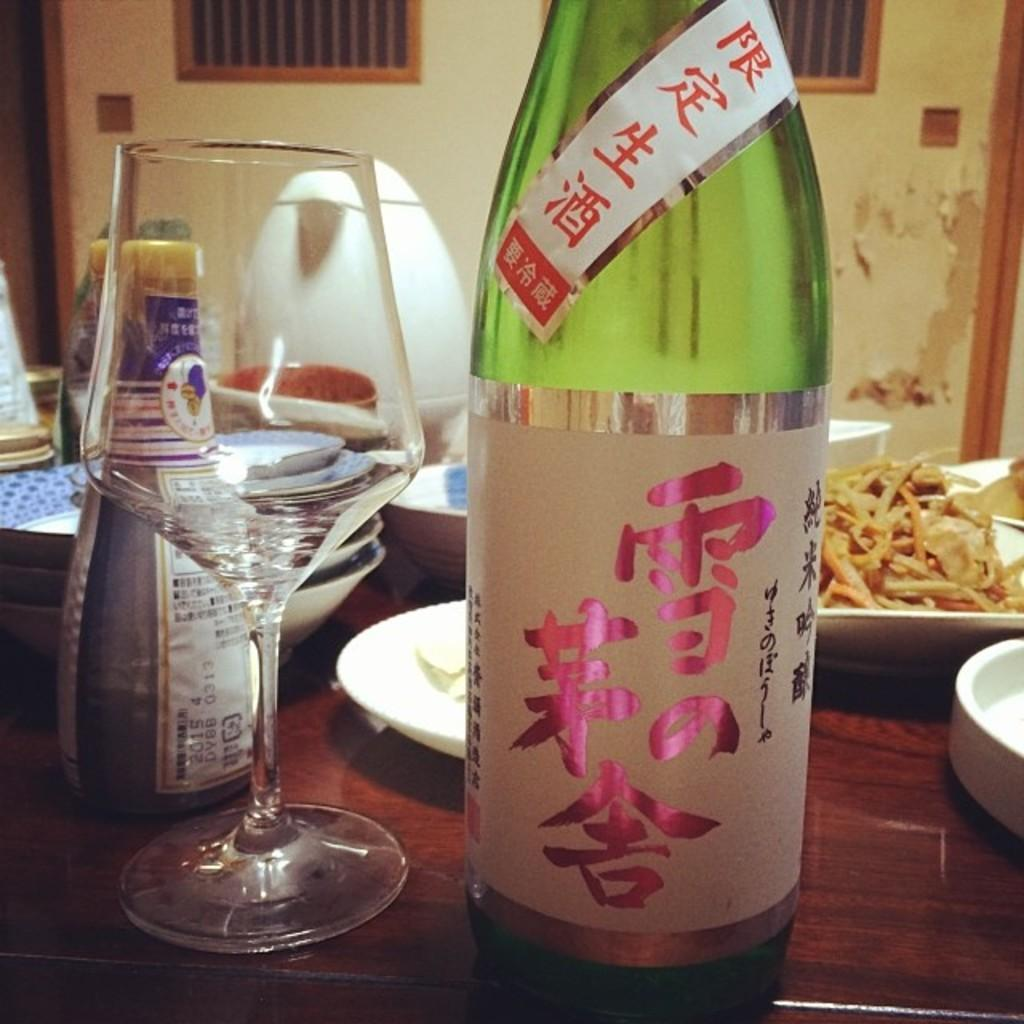What is on the table in the image? There is a bottle, a glass, plates, snacks, and bowls on the table in the image. What type of containers are present on the table? There is a bottle and a glass on the table. What might be used for serving food on the table? The plates and bowls on the table can be used for serving food. What can be seen on the table besides the containers and plates? There are snacks on the table. What is the color of the background in the image? The background of the image is white. How many weeks are depicted in the image? There are no weeks depicted in the image; it features a table with various objects on it. What type of furniture is shown in the image? There is no furniture shown in the image; it only features a table with objects on it. 